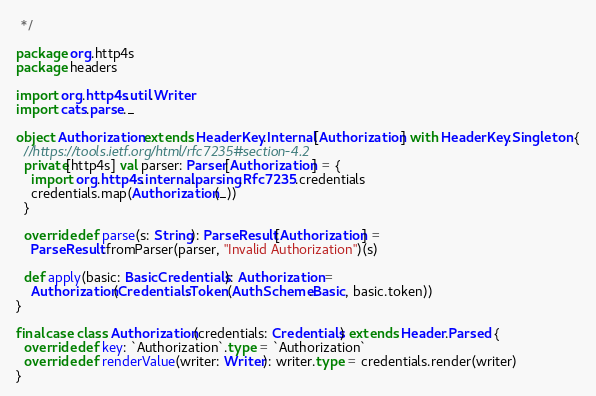Convert code to text. <code><loc_0><loc_0><loc_500><loc_500><_Scala_> */

package org.http4s
package headers

import org.http4s.util.Writer
import cats.parse._

object Authorization extends HeaderKey.Internal[Authorization] with HeaderKey.Singleton {
  //https://tools.ietf.org/html/rfc7235#section-4.2
  private[http4s] val parser: Parser[Authorization] = {
    import org.http4s.internal.parsing.Rfc7235.credentials
    credentials.map(Authorization(_))
  }

  override def parse(s: String): ParseResult[Authorization] =
    ParseResult.fromParser(parser, "Invalid Authorization")(s)

  def apply(basic: BasicCredentials): Authorization =
    Authorization(Credentials.Token(AuthScheme.Basic, basic.token))
}

final case class Authorization(credentials: Credentials) extends Header.Parsed {
  override def key: `Authorization`.type = `Authorization`
  override def renderValue(writer: Writer): writer.type = credentials.render(writer)
}
</code> 